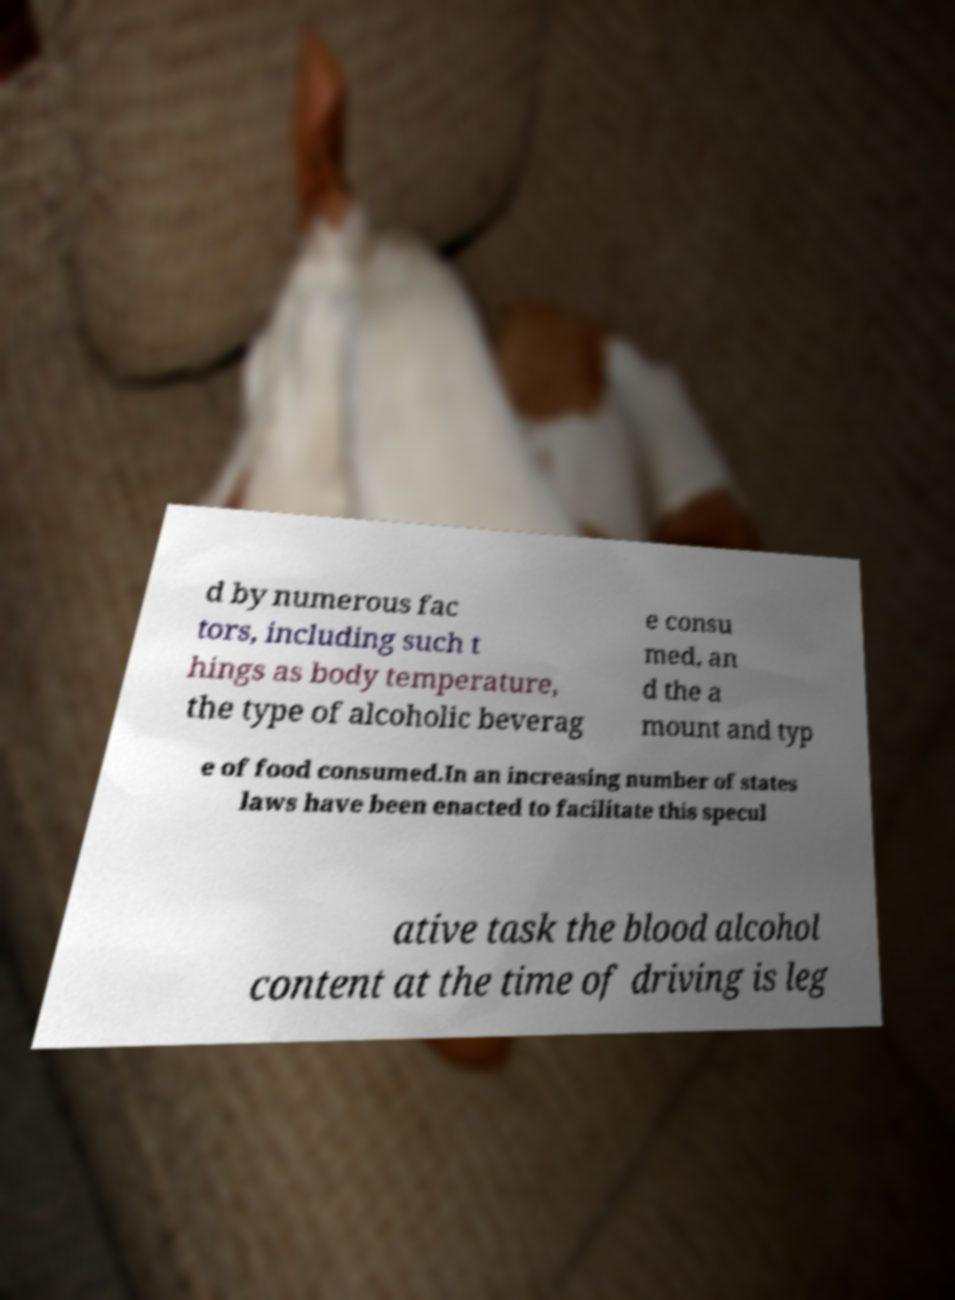Could you extract and type out the text from this image? d by numerous fac tors, including such t hings as body temperature, the type of alcoholic beverag e consu med, an d the a mount and typ e of food consumed.In an increasing number of states laws have been enacted to facilitate this specul ative task the blood alcohol content at the time of driving is leg 